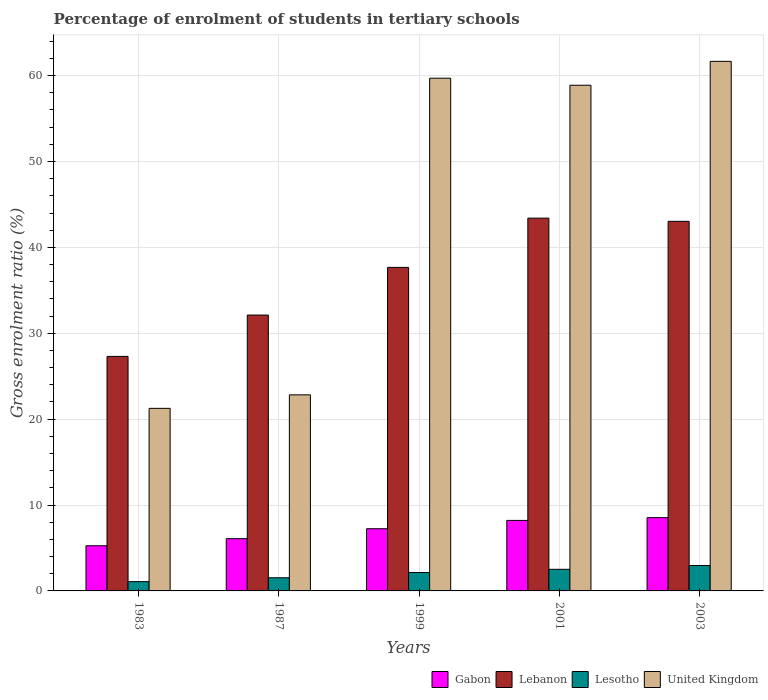How many different coloured bars are there?
Offer a very short reply. 4. How many groups of bars are there?
Your answer should be compact. 5. Are the number of bars on each tick of the X-axis equal?
Offer a terse response. Yes. What is the label of the 3rd group of bars from the left?
Offer a very short reply. 1999. In how many cases, is the number of bars for a given year not equal to the number of legend labels?
Keep it short and to the point. 0. What is the percentage of students enrolled in tertiary schools in United Kingdom in 1999?
Give a very brief answer. 59.7. Across all years, what is the maximum percentage of students enrolled in tertiary schools in Lesotho?
Make the answer very short. 2.96. Across all years, what is the minimum percentage of students enrolled in tertiary schools in Lesotho?
Make the answer very short. 1.08. In which year was the percentage of students enrolled in tertiary schools in Gabon minimum?
Make the answer very short. 1983. What is the total percentage of students enrolled in tertiary schools in Gabon in the graph?
Offer a terse response. 35.33. What is the difference between the percentage of students enrolled in tertiary schools in Lebanon in 1987 and that in 2001?
Your answer should be very brief. -11.28. What is the difference between the percentage of students enrolled in tertiary schools in Gabon in 2001 and the percentage of students enrolled in tertiary schools in Lesotho in 1999?
Offer a terse response. 6.07. What is the average percentage of students enrolled in tertiary schools in Lesotho per year?
Your answer should be compact. 2.05. In the year 1987, what is the difference between the percentage of students enrolled in tertiary schools in United Kingdom and percentage of students enrolled in tertiary schools in Lesotho?
Provide a succinct answer. 21.3. In how many years, is the percentage of students enrolled in tertiary schools in Lebanon greater than 20 %?
Keep it short and to the point. 5. What is the ratio of the percentage of students enrolled in tertiary schools in Lebanon in 1983 to that in 1987?
Offer a very short reply. 0.85. Is the percentage of students enrolled in tertiary schools in Lesotho in 1983 less than that in 1999?
Offer a terse response. Yes. Is the difference between the percentage of students enrolled in tertiary schools in United Kingdom in 1987 and 2003 greater than the difference between the percentage of students enrolled in tertiary schools in Lesotho in 1987 and 2003?
Give a very brief answer. No. What is the difference between the highest and the second highest percentage of students enrolled in tertiary schools in United Kingdom?
Provide a succinct answer. 1.96. What is the difference between the highest and the lowest percentage of students enrolled in tertiary schools in United Kingdom?
Your response must be concise. 40.4. Is the sum of the percentage of students enrolled in tertiary schools in Lesotho in 1983 and 1999 greater than the maximum percentage of students enrolled in tertiary schools in Gabon across all years?
Offer a terse response. No. What does the 2nd bar from the left in 1983 represents?
Keep it short and to the point. Lebanon. What does the 3rd bar from the right in 1999 represents?
Give a very brief answer. Lebanon. How many bars are there?
Your answer should be very brief. 20. Are all the bars in the graph horizontal?
Provide a succinct answer. No. What is the difference between two consecutive major ticks on the Y-axis?
Your response must be concise. 10. Does the graph contain any zero values?
Your answer should be very brief. No. Does the graph contain grids?
Your answer should be compact. Yes. Where does the legend appear in the graph?
Offer a terse response. Bottom right. How many legend labels are there?
Offer a very short reply. 4. What is the title of the graph?
Keep it short and to the point. Percentage of enrolment of students in tertiary schools. What is the label or title of the Y-axis?
Offer a terse response. Gross enrolment ratio (%). What is the Gross enrolment ratio (%) of Gabon in 1983?
Give a very brief answer. 5.26. What is the Gross enrolment ratio (%) of Lebanon in 1983?
Your answer should be compact. 27.3. What is the Gross enrolment ratio (%) of Lesotho in 1983?
Your answer should be compact. 1.08. What is the Gross enrolment ratio (%) in United Kingdom in 1983?
Provide a succinct answer. 21.26. What is the Gross enrolment ratio (%) of Gabon in 1987?
Your response must be concise. 6.08. What is the Gross enrolment ratio (%) of Lebanon in 1987?
Give a very brief answer. 32.12. What is the Gross enrolment ratio (%) of Lesotho in 1987?
Provide a short and direct response. 1.53. What is the Gross enrolment ratio (%) of United Kingdom in 1987?
Give a very brief answer. 22.83. What is the Gross enrolment ratio (%) of Gabon in 1999?
Make the answer very short. 7.24. What is the Gross enrolment ratio (%) of Lebanon in 1999?
Your response must be concise. 37.67. What is the Gross enrolment ratio (%) of Lesotho in 1999?
Keep it short and to the point. 2.14. What is the Gross enrolment ratio (%) of United Kingdom in 1999?
Your answer should be compact. 59.7. What is the Gross enrolment ratio (%) in Gabon in 2001?
Give a very brief answer. 8.21. What is the Gross enrolment ratio (%) in Lebanon in 2001?
Provide a succinct answer. 43.4. What is the Gross enrolment ratio (%) in Lesotho in 2001?
Keep it short and to the point. 2.52. What is the Gross enrolment ratio (%) in United Kingdom in 2001?
Provide a succinct answer. 58.88. What is the Gross enrolment ratio (%) in Gabon in 2003?
Provide a succinct answer. 8.53. What is the Gross enrolment ratio (%) in Lebanon in 2003?
Provide a short and direct response. 43.03. What is the Gross enrolment ratio (%) in Lesotho in 2003?
Your answer should be compact. 2.96. What is the Gross enrolment ratio (%) of United Kingdom in 2003?
Provide a short and direct response. 61.66. Across all years, what is the maximum Gross enrolment ratio (%) in Gabon?
Give a very brief answer. 8.53. Across all years, what is the maximum Gross enrolment ratio (%) in Lebanon?
Ensure brevity in your answer.  43.4. Across all years, what is the maximum Gross enrolment ratio (%) of Lesotho?
Give a very brief answer. 2.96. Across all years, what is the maximum Gross enrolment ratio (%) of United Kingdom?
Your response must be concise. 61.66. Across all years, what is the minimum Gross enrolment ratio (%) of Gabon?
Ensure brevity in your answer.  5.26. Across all years, what is the minimum Gross enrolment ratio (%) of Lebanon?
Keep it short and to the point. 27.3. Across all years, what is the minimum Gross enrolment ratio (%) in Lesotho?
Provide a short and direct response. 1.08. Across all years, what is the minimum Gross enrolment ratio (%) of United Kingdom?
Give a very brief answer. 21.26. What is the total Gross enrolment ratio (%) in Gabon in the graph?
Your response must be concise. 35.33. What is the total Gross enrolment ratio (%) of Lebanon in the graph?
Your response must be concise. 183.52. What is the total Gross enrolment ratio (%) of Lesotho in the graph?
Ensure brevity in your answer.  10.23. What is the total Gross enrolment ratio (%) in United Kingdom in the graph?
Give a very brief answer. 224.31. What is the difference between the Gross enrolment ratio (%) of Gabon in 1983 and that in 1987?
Offer a terse response. -0.82. What is the difference between the Gross enrolment ratio (%) in Lebanon in 1983 and that in 1987?
Your response must be concise. -4.81. What is the difference between the Gross enrolment ratio (%) of Lesotho in 1983 and that in 1987?
Make the answer very short. -0.45. What is the difference between the Gross enrolment ratio (%) of United Kingdom in 1983 and that in 1987?
Ensure brevity in your answer.  -1.57. What is the difference between the Gross enrolment ratio (%) of Gabon in 1983 and that in 1999?
Your answer should be compact. -1.98. What is the difference between the Gross enrolment ratio (%) of Lebanon in 1983 and that in 1999?
Provide a succinct answer. -10.36. What is the difference between the Gross enrolment ratio (%) in Lesotho in 1983 and that in 1999?
Offer a terse response. -1.06. What is the difference between the Gross enrolment ratio (%) of United Kingdom in 1983 and that in 1999?
Offer a terse response. -38.44. What is the difference between the Gross enrolment ratio (%) of Gabon in 1983 and that in 2001?
Offer a very short reply. -2.95. What is the difference between the Gross enrolment ratio (%) of Lebanon in 1983 and that in 2001?
Make the answer very short. -16.1. What is the difference between the Gross enrolment ratio (%) of Lesotho in 1983 and that in 2001?
Ensure brevity in your answer.  -1.44. What is the difference between the Gross enrolment ratio (%) in United Kingdom in 1983 and that in 2001?
Offer a very short reply. -37.62. What is the difference between the Gross enrolment ratio (%) in Gabon in 1983 and that in 2003?
Provide a short and direct response. -3.27. What is the difference between the Gross enrolment ratio (%) of Lebanon in 1983 and that in 2003?
Give a very brief answer. -15.73. What is the difference between the Gross enrolment ratio (%) in Lesotho in 1983 and that in 2003?
Make the answer very short. -1.88. What is the difference between the Gross enrolment ratio (%) of United Kingdom in 1983 and that in 2003?
Offer a very short reply. -40.4. What is the difference between the Gross enrolment ratio (%) of Gabon in 1987 and that in 1999?
Give a very brief answer. -1.16. What is the difference between the Gross enrolment ratio (%) in Lebanon in 1987 and that in 1999?
Keep it short and to the point. -5.55. What is the difference between the Gross enrolment ratio (%) in Lesotho in 1987 and that in 1999?
Keep it short and to the point. -0.61. What is the difference between the Gross enrolment ratio (%) of United Kingdom in 1987 and that in 1999?
Make the answer very short. -36.87. What is the difference between the Gross enrolment ratio (%) of Gabon in 1987 and that in 2001?
Your response must be concise. -2.13. What is the difference between the Gross enrolment ratio (%) of Lebanon in 1987 and that in 2001?
Make the answer very short. -11.28. What is the difference between the Gross enrolment ratio (%) of Lesotho in 1987 and that in 2001?
Make the answer very short. -0.98. What is the difference between the Gross enrolment ratio (%) of United Kingdom in 1987 and that in 2001?
Offer a very short reply. -36.05. What is the difference between the Gross enrolment ratio (%) in Gabon in 1987 and that in 2003?
Keep it short and to the point. -2.45. What is the difference between the Gross enrolment ratio (%) of Lebanon in 1987 and that in 2003?
Provide a succinct answer. -10.91. What is the difference between the Gross enrolment ratio (%) of Lesotho in 1987 and that in 2003?
Offer a very short reply. -1.43. What is the difference between the Gross enrolment ratio (%) in United Kingdom in 1987 and that in 2003?
Provide a succinct answer. -38.83. What is the difference between the Gross enrolment ratio (%) of Gabon in 1999 and that in 2001?
Keep it short and to the point. -0.97. What is the difference between the Gross enrolment ratio (%) of Lebanon in 1999 and that in 2001?
Provide a succinct answer. -5.73. What is the difference between the Gross enrolment ratio (%) of Lesotho in 1999 and that in 2001?
Give a very brief answer. -0.38. What is the difference between the Gross enrolment ratio (%) in United Kingdom in 1999 and that in 2001?
Keep it short and to the point. 0.82. What is the difference between the Gross enrolment ratio (%) of Gabon in 1999 and that in 2003?
Your response must be concise. -1.29. What is the difference between the Gross enrolment ratio (%) of Lebanon in 1999 and that in 2003?
Make the answer very short. -5.36. What is the difference between the Gross enrolment ratio (%) of Lesotho in 1999 and that in 2003?
Your answer should be very brief. -0.82. What is the difference between the Gross enrolment ratio (%) in United Kingdom in 1999 and that in 2003?
Ensure brevity in your answer.  -1.96. What is the difference between the Gross enrolment ratio (%) of Gabon in 2001 and that in 2003?
Your response must be concise. -0.32. What is the difference between the Gross enrolment ratio (%) in Lebanon in 2001 and that in 2003?
Provide a short and direct response. 0.37. What is the difference between the Gross enrolment ratio (%) of Lesotho in 2001 and that in 2003?
Offer a terse response. -0.44. What is the difference between the Gross enrolment ratio (%) of United Kingdom in 2001 and that in 2003?
Keep it short and to the point. -2.78. What is the difference between the Gross enrolment ratio (%) of Gabon in 1983 and the Gross enrolment ratio (%) of Lebanon in 1987?
Offer a very short reply. -26.86. What is the difference between the Gross enrolment ratio (%) of Gabon in 1983 and the Gross enrolment ratio (%) of Lesotho in 1987?
Keep it short and to the point. 3.73. What is the difference between the Gross enrolment ratio (%) in Gabon in 1983 and the Gross enrolment ratio (%) in United Kingdom in 1987?
Give a very brief answer. -17.57. What is the difference between the Gross enrolment ratio (%) of Lebanon in 1983 and the Gross enrolment ratio (%) of Lesotho in 1987?
Your answer should be compact. 25.77. What is the difference between the Gross enrolment ratio (%) in Lebanon in 1983 and the Gross enrolment ratio (%) in United Kingdom in 1987?
Give a very brief answer. 4.48. What is the difference between the Gross enrolment ratio (%) in Lesotho in 1983 and the Gross enrolment ratio (%) in United Kingdom in 1987?
Make the answer very short. -21.75. What is the difference between the Gross enrolment ratio (%) of Gabon in 1983 and the Gross enrolment ratio (%) of Lebanon in 1999?
Make the answer very short. -32.41. What is the difference between the Gross enrolment ratio (%) in Gabon in 1983 and the Gross enrolment ratio (%) in Lesotho in 1999?
Keep it short and to the point. 3.12. What is the difference between the Gross enrolment ratio (%) in Gabon in 1983 and the Gross enrolment ratio (%) in United Kingdom in 1999?
Keep it short and to the point. -54.44. What is the difference between the Gross enrolment ratio (%) of Lebanon in 1983 and the Gross enrolment ratio (%) of Lesotho in 1999?
Your answer should be compact. 25.16. What is the difference between the Gross enrolment ratio (%) of Lebanon in 1983 and the Gross enrolment ratio (%) of United Kingdom in 1999?
Make the answer very short. -32.39. What is the difference between the Gross enrolment ratio (%) in Lesotho in 1983 and the Gross enrolment ratio (%) in United Kingdom in 1999?
Make the answer very short. -58.62. What is the difference between the Gross enrolment ratio (%) of Gabon in 1983 and the Gross enrolment ratio (%) of Lebanon in 2001?
Offer a terse response. -38.14. What is the difference between the Gross enrolment ratio (%) of Gabon in 1983 and the Gross enrolment ratio (%) of Lesotho in 2001?
Offer a terse response. 2.74. What is the difference between the Gross enrolment ratio (%) in Gabon in 1983 and the Gross enrolment ratio (%) in United Kingdom in 2001?
Your answer should be compact. -53.61. What is the difference between the Gross enrolment ratio (%) in Lebanon in 1983 and the Gross enrolment ratio (%) in Lesotho in 2001?
Give a very brief answer. 24.79. What is the difference between the Gross enrolment ratio (%) of Lebanon in 1983 and the Gross enrolment ratio (%) of United Kingdom in 2001?
Provide a succinct answer. -31.57. What is the difference between the Gross enrolment ratio (%) of Lesotho in 1983 and the Gross enrolment ratio (%) of United Kingdom in 2001?
Your answer should be very brief. -57.79. What is the difference between the Gross enrolment ratio (%) of Gabon in 1983 and the Gross enrolment ratio (%) of Lebanon in 2003?
Make the answer very short. -37.77. What is the difference between the Gross enrolment ratio (%) of Gabon in 1983 and the Gross enrolment ratio (%) of Lesotho in 2003?
Your answer should be very brief. 2.3. What is the difference between the Gross enrolment ratio (%) in Gabon in 1983 and the Gross enrolment ratio (%) in United Kingdom in 2003?
Your answer should be very brief. -56.4. What is the difference between the Gross enrolment ratio (%) of Lebanon in 1983 and the Gross enrolment ratio (%) of Lesotho in 2003?
Provide a short and direct response. 24.35. What is the difference between the Gross enrolment ratio (%) in Lebanon in 1983 and the Gross enrolment ratio (%) in United Kingdom in 2003?
Keep it short and to the point. -34.35. What is the difference between the Gross enrolment ratio (%) of Lesotho in 1983 and the Gross enrolment ratio (%) of United Kingdom in 2003?
Give a very brief answer. -60.58. What is the difference between the Gross enrolment ratio (%) of Gabon in 1987 and the Gross enrolment ratio (%) of Lebanon in 1999?
Offer a terse response. -31.59. What is the difference between the Gross enrolment ratio (%) of Gabon in 1987 and the Gross enrolment ratio (%) of Lesotho in 1999?
Keep it short and to the point. 3.94. What is the difference between the Gross enrolment ratio (%) of Gabon in 1987 and the Gross enrolment ratio (%) of United Kingdom in 1999?
Offer a terse response. -53.61. What is the difference between the Gross enrolment ratio (%) in Lebanon in 1987 and the Gross enrolment ratio (%) in Lesotho in 1999?
Your answer should be very brief. 29.98. What is the difference between the Gross enrolment ratio (%) in Lebanon in 1987 and the Gross enrolment ratio (%) in United Kingdom in 1999?
Your answer should be very brief. -27.58. What is the difference between the Gross enrolment ratio (%) in Lesotho in 1987 and the Gross enrolment ratio (%) in United Kingdom in 1999?
Make the answer very short. -58.17. What is the difference between the Gross enrolment ratio (%) in Gabon in 1987 and the Gross enrolment ratio (%) in Lebanon in 2001?
Your answer should be compact. -37.32. What is the difference between the Gross enrolment ratio (%) in Gabon in 1987 and the Gross enrolment ratio (%) in Lesotho in 2001?
Keep it short and to the point. 3.57. What is the difference between the Gross enrolment ratio (%) of Gabon in 1987 and the Gross enrolment ratio (%) of United Kingdom in 2001?
Offer a very short reply. -52.79. What is the difference between the Gross enrolment ratio (%) in Lebanon in 1987 and the Gross enrolment ratio (%) in Lesotho in 2001?
Provide a short and direct response. 29.6. What is the difference between the Gross enrolment ratio (%) of Lebanon in 1987 and the Gross enrolment ratio (%) of United Kingdom in 2001?
Give a very brief answer. -26.76. What is the difference between the Gross enrolment ratio (%) of Lesotho in 1987 and the Gross enrolment ratio (%) of United Kingdom in 2001?
Your answer should be compact. -57.34. What is the difference between the Gross enrolment ratio (%) in Gabon in 1987 and the Gross enrolment ratio (%) in Lebanon in 2003?
Ensure brevity in your answer.  -36.95. What is the difference between the Gross enrolment ratio (%) in Gabon in 1987 and the Gross enrolment ratio (%) in Lesotho in 2003?
Your answer should be very brief. 3.13. What is the difference between the Gross enrolment ratio (%) of Gabon in 1987 and the Gross enrolment ratio (%) of United Kingdom in 2003?
Offer a very short reply. -55.57. What is the difference between the Gross enrolment ratio (%) in Lebanon in 1987 and the Gross enrolment ratio (%) in Lesotho in 2003?
Your answer should be compact. 29.16. What is the difference between the Gross enrolment ratio (%) of Lebanon in 1987 and the Gross enrolment ratio (%) of United Kingdom in 2003?
Your response must be concise. -29.54. What is the difference between the Gross enrolment ratio (%) in Lesotho in 1987 and the Gross enrolment ratio (%) in United Kingdom in 2003?
Make the answer very short. -60.13. What is the difference between the Gross enrolment ratio (%) in Gabon in 1999 and the Gross enrolment ratio (%) in Lebanon in 2001?
Offer a terse response. -36.16. What is the difference between the Gross enrolment ratio (%) of Gabon in 1999 and the Gross enrolment ratio (%) of Lesotho in 2001?
Keep it short and to the point. 4.73. What is the difference between the Gross enrolment ratio (%) in Gabon in 1999 and the Gross enrolment ratio (%) in United Kingdom in 2001?
Your answer should be compact. -51.63. What is the difference between the Gross enrolment ratio (%) of Lebanon in 1999 and the Gross enrolment ratio (%) of Lesotho in 2001?
Your answer should be compact. 35.15. What is the difference between the Gross enrolment ratio (%) of Lebanon in 1999 and the Gross enrolment ratio (%) of United Kingdom in 2001?
Your answer should be compact. -21.21. What is the difference between the Gross enrolment ratio (%) in Lesotho in 1999 and the Gross enrolment ratio (%) in United Kingdom in 2001?
Ensure brevity in your answer.  -56.73. What is the difference between the Gross enrolment ratio (%) of Gabon in 1999 and the Gross enrolment ratio (%) of Lebanon in 2003?
Make the answer very short. -35.79. What is the difference between the Gross enrolment ratio (%) of Gabon in 1999 and the Gross enrolment ratio (%) of Lesotho in 2003?
Offer a very short reply. 4.28. What is the difference between the Gross enrolment ratio (%) of Gabon in 1999 and the Gross enrolment ratio (%) of United Kingdom in 2003?
Make the answer very short. -54.42. What is the difference between the Gross enrolment ratio (%) in Lebanon in 1999 and the Gross enrolment ratio (%) in Lesotho in 2003?
Your response must be concise. 34.71. What is the difference between the Gross enrolment ratio (%) in Lebanon in 1999 and the Gross enrolment ratio (%) in United Kingdom in 2003?
Keep it short and to the point. -23.99. What is the difference between the Gross enrolment ratio (%) of Lesotho in 1999 and the Gross enrolment ratio (%) of United Kingdom in 2003?
Keep it short and to the point. -59.52. What is the difference between the Gross enrolment ratio (%) in Gabon in 2001 and the Gross enrolment ratio (%) in Lebanon in 2003?
Give a very brief answer. -34.82. What is the difference between the Gross enrolment ratio (%) in Gabon in 2001 and the Gross enrolment ratio (%) in Lesotho in 2003?
Keep it short and to the point. 5.25. What is the difference between the Gross enrolment ratio (%) of Gabon in 2001 and the Gross enrolment ratio (%) of United Kingdom in 2003?
Keep it short and to the point. -53.45. What is the difference between the Gross enrolment ratio (%) of Lebanon in 2001 and the Gross enrolment ratio (%) of Lesotho in 2003?
Ensure brevity in your answer.  40.44. What is the difference between the Gross enrolment ratio (%) in Lebanon in 2001 and the Gross enrolment ratio (%) in United Kingdom in 2003?
Offer a very short reply. -18.26. What is the difference between the Gross enrolment ratio (%) of Lesotho in 2001 and the Gross enrolment ratio (%) of United Kingdom in 2003?
Make the answer very short. -59.14. What is the average Gross enrolment ratio (%) of Gabon per year?
Your answer should be compact. 7.07. What is the average Gross enrolment ratio (%) of Lebanon per year?
Your response must be concise. 36.7. What is the average Gross enrolment ratio (%) of Lesotho per year?
Your response must be concise. 2.05. What is the average Gross enrolment ratio (%) in United Kingdom per year?
Your response must be concise. 44.86. In the year 1983, what is the difference between the Gross enrolment ratio (%) in Gabon and Gross enrolment ratio (%) in Lebanon?
Your answer should be compact. -22.04. In the year 1983, what is the difference between the Gross enrolment ratio (%) of Gabon and Gross enrolment ratio (%) of Lesotho?
Provide a short and direct response. 4.18. In the year 1983, what is the difference between the Gross enrolment ratio (%) in Gabon and Gross enrolment ratio (%) in United Kingdom?
Keep it short and to the point. -16. In the year 1983, what is the difference between the Gross enrolment ratio (%) in Lebanon and Gross enrolment ratio (%) in Lesotho?
Provide a succinct answer. 26.22. In the year 1983, what is the difference between the Gross enrolment ratio (%) in Lebanon and Gross enrolment ratio (%) in United Kingdom?
Ensure brevity in your answer.  6.05. In the year 1983, what is the difference between the Gross enrolment ratio (%) in Lesotho and Gross enrolment ratio (%) in United Kingdom?
Your response must be concise. -20.18. In the year 1987, what is the difference between the Gross enrolment ratio (%) in Gabon and Gross enrolment ratio (%) in Lebanon?
Make the answer very short. -26.04. In the year 1987, what is the difference between the Gross enrolment ratio (%) in Gabon and Gross enrolment ratio (%) in Lesotho?
Give a very brief answer. 4.55. In the year 1987, what is the difference between the Gross enrolment ratio (%) in Gabon and Gross enrolment ratio (%) in United Kingdom?
Provide a succinct answer. -16.75. In the year 1987, what is the difference between the Gross enrolment ratio (%) in Lebanon and Gross enrolment ratio (%) in Lesotho?
Provide a succinct answer. 30.59. In the year 1987, what is the difference between the Gross enrolment ratio (%) of Lebanon and Gross enrolment ratio (%) of United Kingdom?
Give a very brief answer. 9.29. In the year 1987, what is the difference between the Gross enrolment ratio (%) in Lesotho and Gross enrolment ratio (%) in United Kingdom?
Offer a very short reply. -21.3. In the year 1999, what is the difference between the Gross enrolment ratio (%) in Gabon and Gross enrolment ratio (%) in Lebanon?
Your answer should be compact. -30.43. In the year 1999, what is the difference between the Gross enrolment ratio (%) in Gabon and Gross enrolment ratio (%) in Lesotho?
Your response must be concise. 5.1. In the year 1999, what is the difference between the Gross enrolment ratio (%) in Gabon and Gross enrolment ratio (%) in United Kingdom?
Make the answer very short. -52.46. In the year 1999, what is the difference between the Gross enrolment ratio (%) in Lebanon and Gross enrolment ratio (%) in Lesotho?
Provide a succinct answer. 35.53. In the year 1999, what is the difference between the Gross enrolment ratio (%) of Lebanon and Gross enrolment ratio (%) of United Kingdom?
Your answer should be very brief. -22.03. In the year 1999, what is the difference between the Gross enrolment ratio (%) in Lesotho and Gross enrolment ratio (%) in United Kingdom?
Ensure brevity in your answer.  -57.56. In the year 2001, what is the difference between the Gross enrolment ratio (%) of Gabon and Gross enrolment ratio (%) of Lebanon?
Offer a terse response. -35.19. In the year 2001, what is the difference between the Gross enrolment ratio (%) of Gabon and Gross enrolment ratio (%) of Lesotho?
Your answer should be compact. 5.69. In the year 2001, what is the difference between the Gross enrolment ratio (%) in Gabon and Gross enrolment ratio (%) in United Kingdom?
Provide a short and direct response. -50.67. In the year 2001, what is the difference between the Gross enrolment ratio (%) in Lebanon and Gross enrolment ratio (%) in Lesotho?
Make the answer very short. 40.88. In the year 2001, what is the difference between the Gross enrolment ratio (%) in Lebanon and Gross enrolment ratio (%) in United Kingdom?
Your response must be concise. -15.47. In the year 2001, what is the difference between the Gross enrolment ratio (%) of Lesotho and Gross enrolment ratio (%) of United Kingdom?
Offer a very short reply. -56.36. In the year 2003, what is the difference between the Gross enrolment ratio (%) in Gabon and Gross enrolment ratio (%) in Lebanon?
Provide a short and direct response. -34.5. In the year 2003, what is the difference between the Gross enrolment ratio (%) of Gabon and Gross enrolment ratio (%) of Lesotho?
Make the answer very short. 5.57. In the year 2003, what is the difference between the Gross enrolment ratio (%) in Gabon and Gross enrolment ratio (%) in United Kingdom?
Offer a terse response. -53.13. In the year 2003, what is the difference between the Gross enrolment ratio (%) in Lebanon and Gross enrolment ratio (%) in Lesotho?
Offer a terse response. 40.07. In the year 2003, what is the difference between the Gross enrolment ratio (%) of Lebanon and Gross enrolment ratio (%) of United Kingdom?
Offer a terse response. -18.63. In the year 2003, what is the difference between the Gross enrolment ratio (%) in Lesotho and Gross enrolment ratio (%) in United Kingdom?
Provide a succinct answer. -58.7. What is the ratio of the Gross enrolment ratio (%) in Gabon in 1983 to that in 1987?
Offer a very short reply. 0.86. What is the ratio of the Gross enrolment ratio (%) in Lebanon in 1983 to that in 1987?
Offer a terse response. 0.85. What is the ratio of the Gross enrolment ratio (%) of Lesotho in 1983 to that in 1987?
Provide a succinct answer. 0.71. What is the ratio of the Gross enrolment ratio (%) in United Kingdom in 1983 to that in 1987?
Your response must be concise. 0.93. What is the ratio of the Gross enrolment ratio (%) of Gabon in 1983 to that in 1999?
Ensure brevity in your answer.  0.73. What is the ratio of the Gross enrolment ratio (%) in Lebanon in 1983 to that in 1999?
Give a very brief answer. 0.72. What is the ratio of the Gross enrolment ratio (%) of Lesotho in 1983 to that in 1999?
Your response must be concise. 0.5. What is the ratio of the Gross enrolment ratio (%) in United Kingdom in 1983 to that in 1999?
Provide a short and direct response. 0.36. What is the ratio of the Gross enrolment ratio (%) of Gabon in 1983 to that in 2001?
Offer a very short reply. 0.64. What is the ratio of the Gross enrolment ratio (%) of Lebanon in 1983 to that in 2001?
Your answer should be very brief. 0.63. What is the ratio of the Gross enrolment ratio (%) in Lesotho in 1983 to that in 2001?
Offer a terse response. 0.43. What is the ratio of the Gross enrolment ratio (%) of United Kingdom in 1983 to that in 2001?
Make the answer very short. 0.36. What is the ratio of the Gross enrolment ratio (%) in Gabon in 1983 to that in 2003?
Provide a succinct answer. 0.62. What is the ratio of the Gross enrolment ratio (%) of Lebanon in 1983 to that in 2003?
Your answer should be compact. 0.63. What is the ratio of the Gross enrolment ratio (%) in Lesotho in 1983 to that in 2003?
Your response must be concise. 0.37. What is the ratio of the Gross enrolment ratio (%) in United Kingdom in 1983 to that in 2003?
Provide a short and direct response. 0.34. What is the ratio of the Gross enrolment ratio (%) of Gabon in 1987 to that in 1999?
Make the answer very short. 0.84. What is the ratio of the Gross enrolment ratio (%) in Lebanon in 1987 to that in 1999?
Your response must be concise. 0.85. What is the ratio of the Gross enrolment ratio (%) of Lesotho in 1987 to that in 1999?
Offer a very short reply. 0.72. What is the ratio of the Gross enrolment ratio (%) in United Kingdom in 1987 to that in 1999?
Your response must be concise. 0.38. What is the ratio of the Gross enrolment ratio (%) of Gabon in 1987 to that in 2001?
Give a very brief answer. 0.74. What is the ratio of the Gross enrolment ratio (%) in Lebanon in 1987 to that in 2001?
Ensure brevity in your answer.  0.74. What is the ratio of the Gross enrolment ratio (%) in Lesotho in 1987 to that in 2001?
Your response must be concise. 0.61. What is the ratio of the Gross enrolment ratio (%) of United Kingdom in 1987 to that in 2001?
Provide a succinct answer. 0.39. What is the ratio of the Gross enrolment ratio (%) in Gabon in 1987 to that in 2003?
Keep it short and to the point. 0.71. What is the ratio of the Gross enrolment ratio (%) in Lebanon in 1987 to that in 2003?
Your answer should be very brief. 0.75. What is the ratio of the Gross enrolment ratio (%) in Lesotho in 1987 to that in 2003?
Your response must be concise. 0.52. What is the ratio of the Gross enrolment ratio (%) in United Kingdom in 1987 to that in 2003?
Give a very brief answer. 0.37. What is the ratio of the Gross enrolment ratio (%) in Gabon in 1999 to that in 2001?
Provide a short and direct response. 0.88. What is the ratio of the Gross enrolment ratio (%) in Lebanon in 1999 to that in 2001?
Your answer should be very brief. 0.87. What is the ratio of the Gross enrolment ratio (%) of Lesotho in 1999 to that in 2001?
Offer a very short reply. 0.85. What is the ratio of the Gross enrolment ratio (%) in Gabon in 1999 to that in 2003?
Provide a short and direct response. 0.85. What is the ratio of the Gross enrolment ratio (%) of Lebanon in 1999 to that in 2003?
Provide a short and direct response. 0.88. What is the ratio of the Gross enrolment ratio (%) in Lesotho in 1999 to that in 2003?
Your answer should be very brief. 0.72. What is the ratio of the Gross enrolment ratio (%) in United Kingdom in 1999 to that in 2003?
Keep it short and to the point. 0.97. What is the ratio of the Gross enrolment ratio (%) in Gabon in 2001 to that in 2003?
Your response must be concise. 0.96. What is the ratio of the Gross enrolment ratio (%) of Lebanon in 2001 to that in 2003?
Offer a terse response. 1.01. What is the ratio of the Gross enrolment ratio (%) of Lesotho in 2001 to that in 2003?
Ensure brevity in your answer.  0.85. What is the ratio of the Gross enrolment ratio (%) in United Kingdom in 2001 to that in 2003?
Keep it short and to the point. 0.95. What is the difference between the highest and the second highest Gross enrolment ratio (%) of Gabon?
Offer a terse response. 0.32. What is the difference between the highest and the second highest Gross enrolment ratio (%) of Lebanon?
Your answer should be very brief. 0.37. What is the difference between the highest and the second highest Gross enrolment ratio (%) of Lesotho?
Offer a very short reply. 0.44. What is the difference between the highest and the second highest Gross enrolment ratio (%) in United Kingdom?
Your response must be concise. 1.96. What is the difference between the highest and the lowest Gross enrolment ratio (%) of Gabon?
Provide a short and direct response. 3.27. What is the difference between the highest and the lowest Gross enrolment ratio (%) of Lebanon?
Provide a succinct answer. 16.1. What is the difference between the highest and the lowest Gross enrolment ratio (%) of Lesotho?
Keep it short and to the point. 1.88. What is the difference between the highest and the lowest Gross enrolment ratio (%) of United Kingdom?
Ensure brevity in your answer.  40.4. 